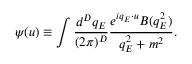<formula> <loc_0><loc_0><loc_500><loc_500>\psi ( u ) \equiv \int \frac { d ^ { D } q _ { E } } { ( 2 \pi ) ^ { D } } \frac { e ^ { i q _ { E } \cdot u } B ( q _ { E } ^ { 2 } ) } { q _ { E } ^ { 2 } + m ^ { 2 } } .</formula> 